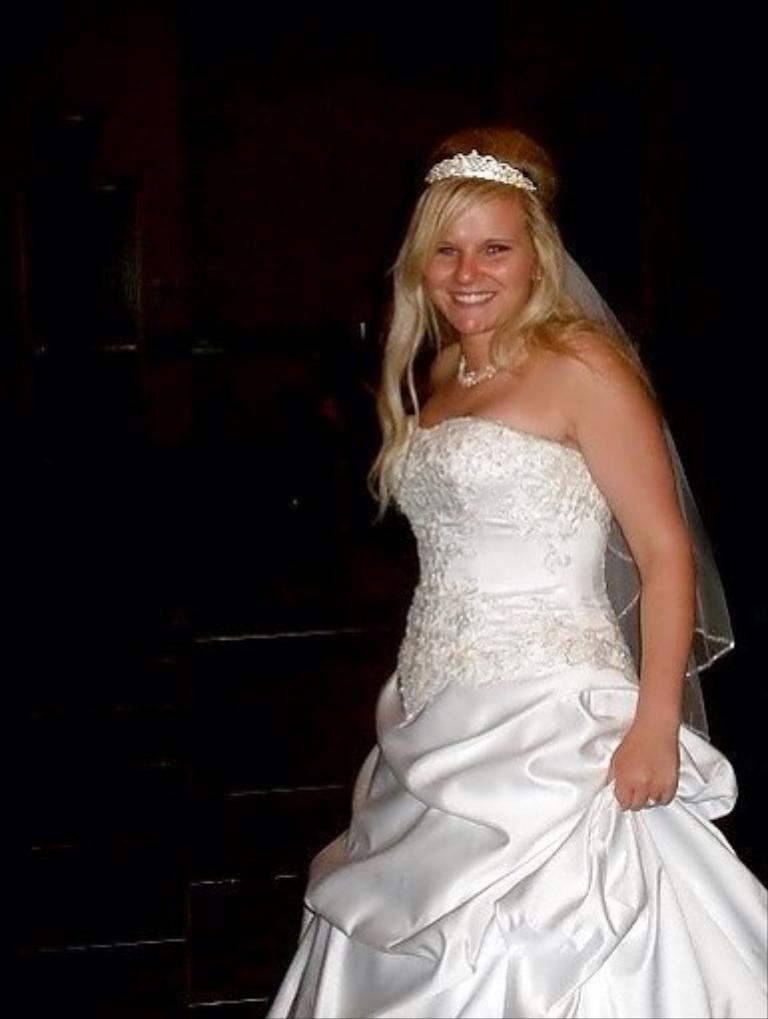Please provide a concise description of this image. This woman wore white frock, crown and smiling. Background it is dark. 